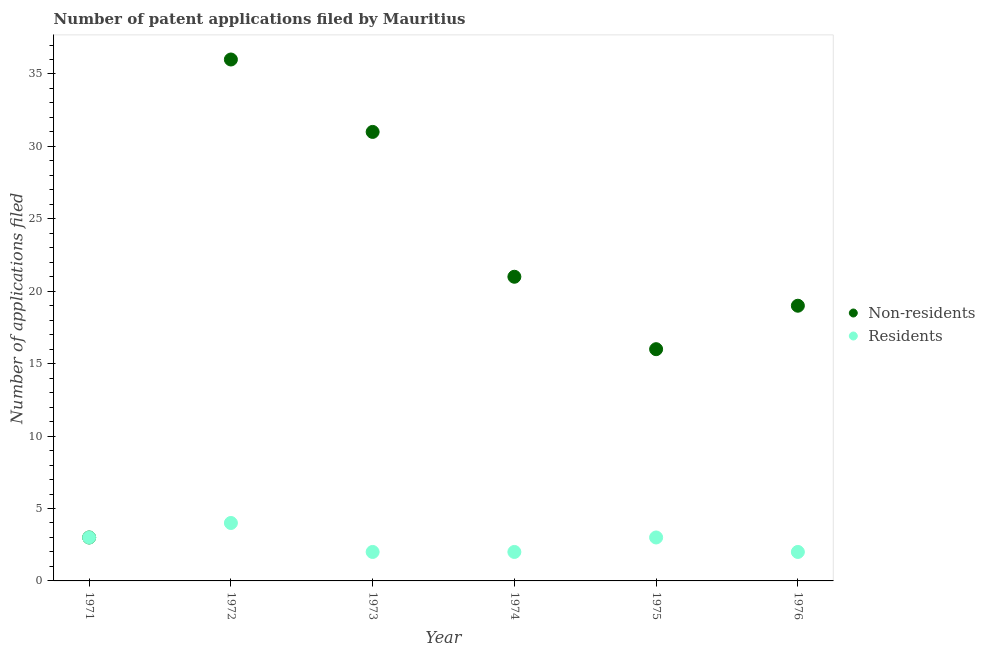Is the number of dotlines equal to the number of legend labels?
Give a very brief answer. Yes. What is the number of patent applications by residents in 1976?
Your response must be concise. 2. Across all years, what is the maximum number of patent applications by residents?
Keep it short and to the point. 4. Across all years, what is the minimum number of patent applications by residents?
Make the answer very short. 2. In which year was the number of patent applications by residents maximum?
Offer a very short reply. 1972. In which year was the number of patent applications by non residents minimum?
Your response must be concise. 1971. What is the total number of patent applications by residents in the graph?
Provide a succinct answer. 16. What is the difference between the number of patent applications by residents in 1974 and the number of patent applications by non residents in 1973?
Offer a terse response. -29. In the year 1975, what is the difference between the number of patent applications by non residents and number of patent applications by residents?
Your answer should be very brief. 13. What is the ratio of the number of patent applications by non residents in 1972 to that in 1975?
Keep it short and to the point. 2.25. Is the difference between the number of patent applications by residents in 1971 and 1972 greater than the difference between the number of patent applications by non residents in 1971 and 1972?
Offer a very short reply. Yes. What is the difference between the highest and the lowest number of patent applications by residents?
Keep it short and to the point. 2. How many dotlines are there?
Offer a terse response. 2. What is the difference between two consecutive major ticks on the Y-axis?
Keep it short and to the point. 5. Does the graph contain any zero values?
Ensure brevity in your answer.  No. Where does the legend appear in the graph?
Your response must be concise. Center right. What is the title of the graph?
Your answer should be very brief. Number of patent applications filed by Mauritius. Does "Crop" appear as one of the legend labels in the graph?
Your response must be concise. No. What is the label or title of the Y-axis?
Offer a very short reply. Number of applications filed. What is the Number of applications filed of Non-residents in 1971?
Your answer should be very brief. 3. What is the Number of applications filed of Residents in 1971?
Ensure brevity in your answer.  3. What is the Number of applications filed in Residents in 1972?
Keep it short and to the point. 4. What is the Number of applications filed in Residents in 1973?
Keep it short and to the point. 2. What is the Number of applications filed in Non-residents in 1974?
Provide a succinct answer. 21. What is the Number of applications filed of Residents in 1974?
Your answer should be very brief. 2. What is the Number of applications filed in Residents in 1975?
Your answer should be very brief. 3. What is the Number of applications filed of Non-residents in 1976?
Provide a short and direct response. 19. What is the Number of applications filed in Residents in 1976?
Offer a very short reply. 2. Across all years, what is the maximum Number of applications filed of Residents?
Your answer should be compact. 4. Across all years, what is the minimum Number of applications filed of Non-residents?
Keep it short and to the point. 3. Across all years, what is the minimum Number of applications filed of Residents?
Give a very brief answer. 2. What is the total Number of applications filed in Non-residents in the graph?
Your answer should be compact. 126. What is the difference between the Number of applications filed in Non-residents in 1971 and that in 1972?
Your answer should be compact. -33. What is the difference between the Number of applications filed in Residents in 1971 and that in 1972?
Make the answer very short. -1. What is the difference between the Number of applications filed of Non-residents in 1971 and that in 1973?
Make the answer very short. -28. What is the difference between the Number of applications filed of Non-residents in 1971 and that in 1974?
Your answer should be compact. -18. What is the difference between the Number of applications filed of Non-residents in 1971 and that in 1975?
Provide a short and direct response. -13. What is the difference between the Number of applications filed of Residents in 1971 and that in 1976?
Provide a short and direct response. 1. What is the difference between the Number of applications filed in Non-residents in 1972 and that in 1974?
Provide a succinct answer. 15. What is the difference between the Number of applications filed in Residents in 1972 and that in 1975?
Give a very brief answer. 1. What is the difference between the Number of applications filed in Residents in 1972 and that in 1976?
Provide a short and direct response. 2. What is the difference between the Number of applications filed in Residents in 1973 and that in 1974?
Give a very brief answer. 0. What is the difference between the Number of applications filed in Non-residents in 1973 and that in 1975?
Provide a short and direct response. 15. What is the difference between the Number of applications filed of Residents in 1973 and that in 1975?
Give a very brief answer. -1. What is the difference between the Number of applications filed of Non-residents in 1973 and that in 1976?
Provide a short and direct response. 12. What is the difference between the Number of applications filed of Residents in 1973 and that in 1976?
Provide a short and direct response. 0. What is the difference between the Number of applications filed in Residents in 1974 and that in 1976?
Your answer should be compact. 0. What is the difference between the Number of applications filed of Non-residents in 1975 and that in 1976?
Give a very brief answer. -3. What is the difference between the Number of applications filed of Residents in 1975 and that in 1976?
Your response must be concise. 1. What is the difference between the Number of applications filed in Non-residents in 1971 and the Number of applications filed in Residents in 1972?
Ensure brevity in your answer.  -1. What is the difference between the Number of applications filed of Non-residents in 1972 and the Number of applications filed of Residents in 1973?
Provide a short and direct response. 34. What is the difference between the Number of applications filed of Non-residents in 1972 and the Number of applications filed of Residents in 1975?
Provide a short and direct response. 33. What is the difference between the Number of applications filed of Non-residents in 1972 and the Number of applications filed of Residents in 1976?
Your answer should be compact. 34. What is the difference between the Number of applications filed of Non-residents in 1973 and the Number of applications filed of Residents in 1974?
Offer a terse response. 29. What is the difference between the Number of applications filed in Non-residents in 1973 and the Number of applications filed in Residents in 1975?
Give a very brief answer. 28. What is the difference between the Number of applications filed in Non-residents in 1973 and the Number of applications filed in Residents in 1976?
Your response must be concise. 29. What is the average Number of applications filed in Residents per year?
Your answer should be very brief. 2.67. In the year 1971, what is the difference between the Number of applications filed of Non-residents and Number of applications filed of Residents?
Provide a succinct answer. 0. In the year 1973, what is the difference between the Number of applications filed of Non-residents and Number of applications filed of Residents?
Your response must be concise. 29. In the year 1975, what is the difference between the Number of applications filed in Non-residents and Number of applications filed in Residents?
Offer a very short reply. 13. What is the ratio of the Number of applications filed in Non-residents in 1971 to that in 1972?
Offer a terse response. 0.08. What is the ratio of the Number of applications filed of Non-residents in 1971 to that in 1973?
Provide a short and direct response. 0.1. What is the ratio of the Number of applications filed of Non-residents in 1971 to that in 1974?
Your response must be concise. 0.14. What is the ratio of the Number of applications filed in Non-residents in 1971 to that in 1975?
Offer a very short reply. 0.19. What is the ratio of the Number of applications filed in Non-residents in 1971 to that in 1976?
Offer a very short reply. 0.16. What is the ratio of the Number of applications filed of Residents in 1971 to that in 1976?
Provide a short and direct response. 1.5. What is the ratio of the Number of applications filed of Non-residents in 1972 to that in 1973?
Keep it short and to the point. 1.16. What is the ratio of the Number of applications filed of Non-residents in 1972 to that in 1974?
Provide a short and direct response. 1.71. What is the ratio of the Number of applications filed of Non-residents in 1972 to that in 1975?
Ensure brevity in your answer.  2.25. What is the ratio of the Number of applications filed of Non-residents in 1972 to that in 1976?
Offer a terse response. 1.89. What is the ratio of the Number of applications filed of Non-residents in 1973 to that in 1974?
Keep it short and to the point. 1.48. What is the ratio of the Number of applications filed of Non-residents in 1973 to that in 1975?
Offer a very short reply. 1.94. What is the ratio of the Number of applications filed of Residents in 1973 to that in 1975?
Your response must be concise. 0.67. What is the ratio of the Number of applications filed in Non-residents in 1973 to that in 1976?
Keep it short and to the point. 1.63. What is the ratio of the Number of applications filed in Non-residents in 1974 to that in 1975?
Keep it short and to the point. 1.31. What is the ratio of the Number of applications filed of Non-residents in 1974 to that in 1976?
Offer a very short reply. 1.11. What is the ratio of the Number of applications filed in Non-residents in 1975 to that in 1976?
Provide a short and direct response. 0.84. What is the difference between the highest and the lowest Number of applications filed of Non-residents?
Give a very brief answer. 33. What is the difference between the highest and the lowest Number of applications filed in Residents?
Offer a very short reply. 2. 